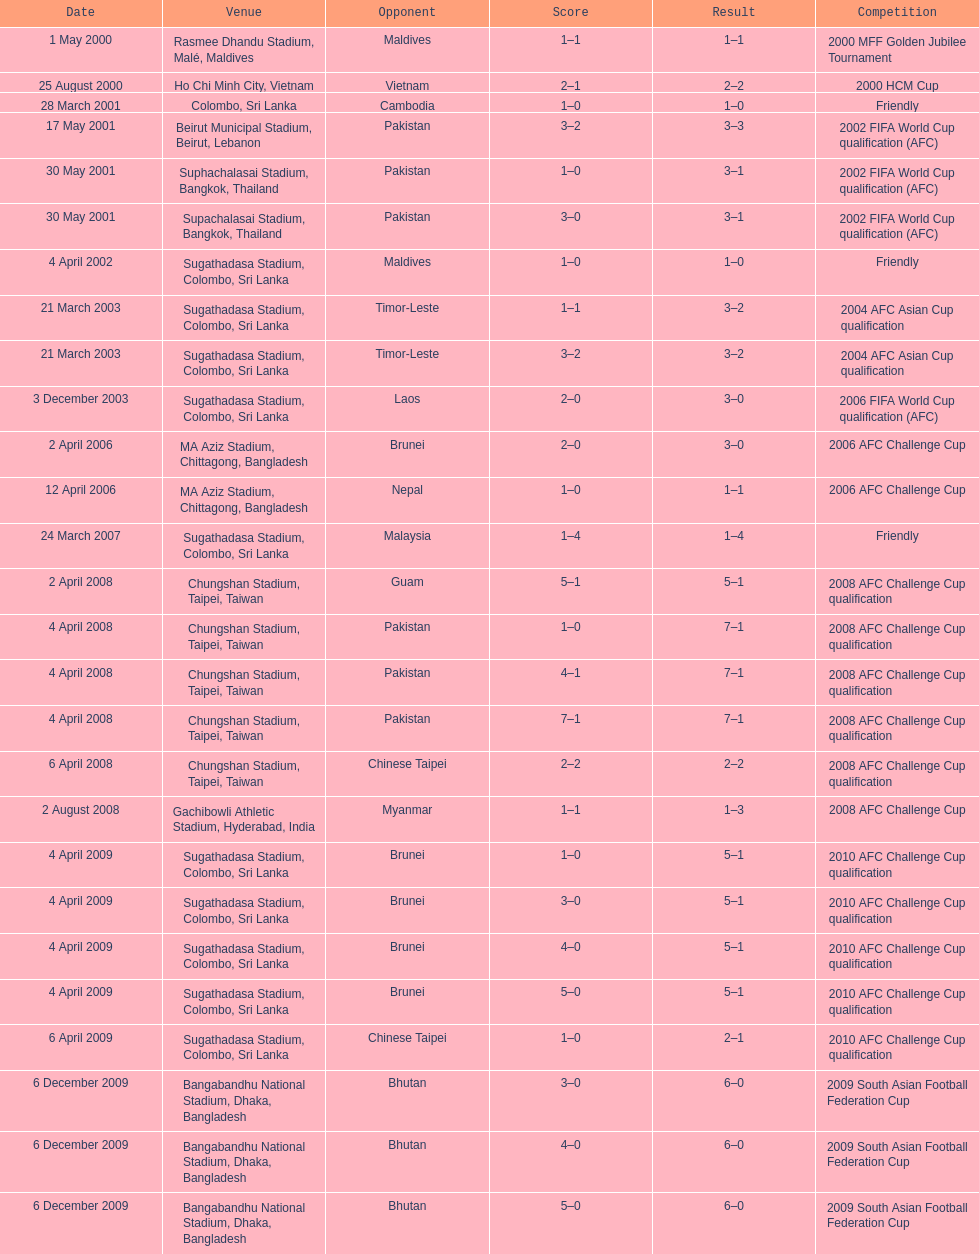What was the next destination after colombo, sri lanka on march 28? Beirut Municipal Stadium, Beirut, Lebanon. 